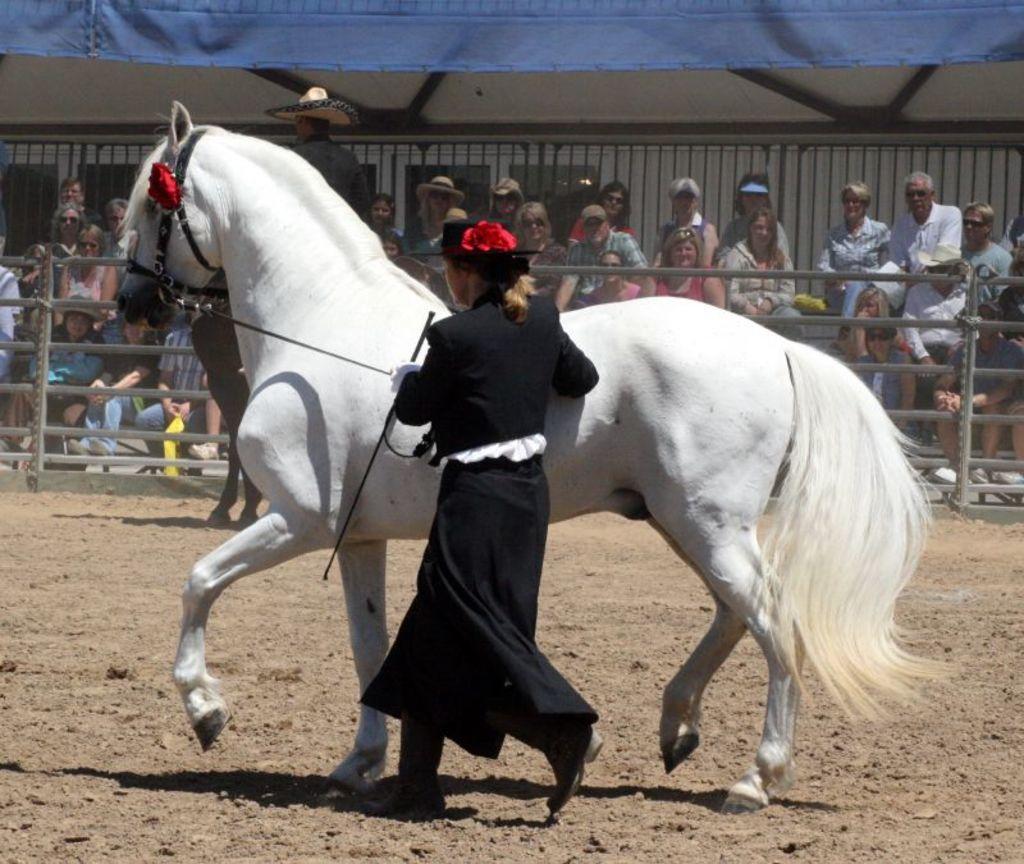Please provide a concise description of this image. In the foreground of the picture there is a woman holding a horse. At the bottom there is soil. In the center of the picture there is a person sitting on the horse and there are people, railing, tent and a building. 